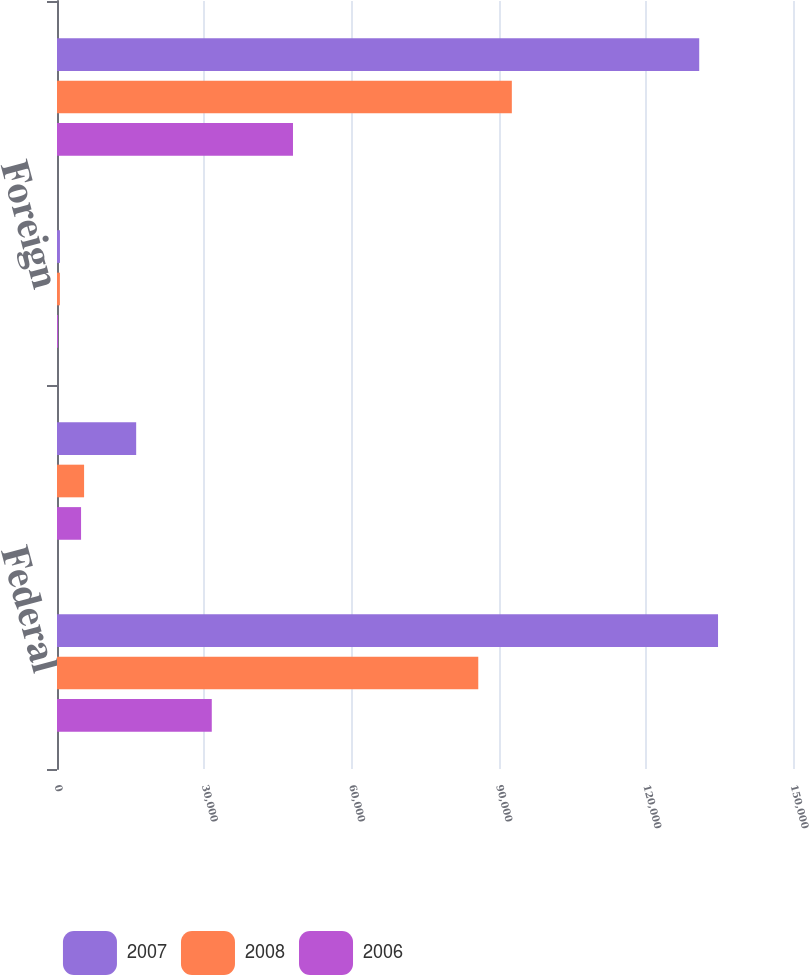Convert chart. <chart><loc_0><loc_0><loc_500><loc_500><stacked_bar_chart><ecel><fcel>Federal<fcel>State<fcel>Foreign<fcel>Total income tax expense<nl><fcel>2007<fcel>134722<fcel>16137<fcel>600<fcel>130888<nl><fcel>2008<fcel>85858<fcel>5521<fcel>590<fcel>92697<nl><fcel>2006<fcel>31543<fcel>4903<fcel>216<fcel>48094<nl></chart> 